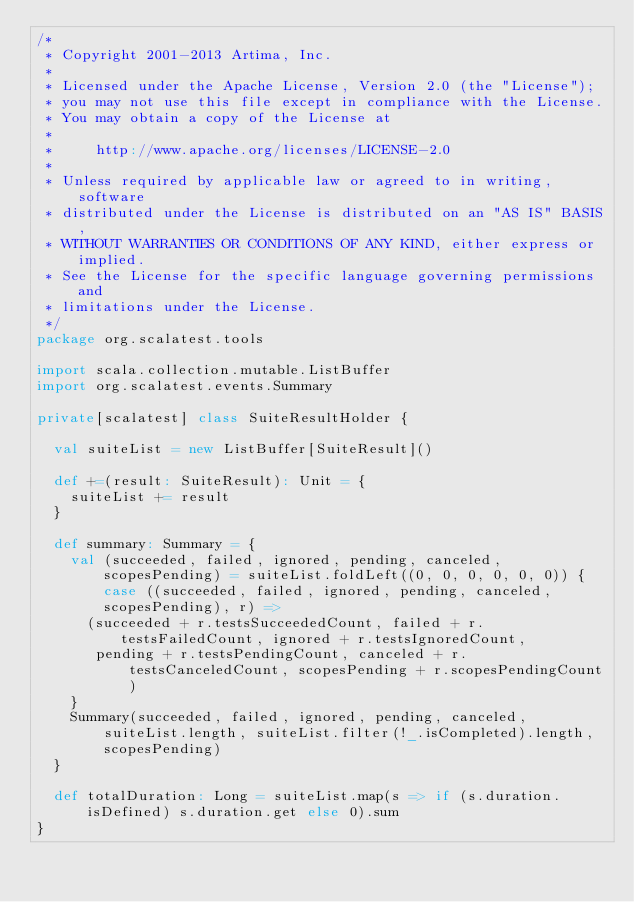Convert code to text. <code><loc_0><loc_0><loc_500><loc_500><_Scala_>/*
 * Copyright 2001-2013 Artima, Inc.
 *
 * Licensed under the Apache License, Version 2.0 (the "License");
 * you may not use this file except in compliance with the License.
 * You may obtain a copy of the License at
 *
 *     http://www.apache.org/licenses/LICENSE-2.0
 *
 * Unless required by applicable law or agreed to in writing, software
 * distributed under the License is distributed on an "AS IS" BASIS,
 * WITHOUT WARRANTIES OR CONDITIONS OF ANY KIND, either express or implied.
 * See the License for the specific language governing permissions and
 * limitations under the License.
 */
package org.scalatest.tools

import scala.collection.mutable.ListBuffer
import org.scalatest.events.Summary

private[scalatest] class SuiteResultHolder {

  val suiteList = new ListBuffer[SuiteResult]()
  
  def +=(result: SuiteResult): Unit = {
    suiteList += result
  }
  
  def summary: Summary = {
    val (succeeded, failed, ignored, pending, canceled, scopesPending) = suiteList.foldLeft((0, 0, 0, 0, 0, 0)) { case ((succeeded, failed, ignored, pending, canceled, scopesPending), r) =>
      (succeeded + r.testsSucceededCount, failed + r.testsFailedCount, ignored + r.testsIgnoredCount, 
       pending + r.testsPendingCount, canceled + r.testsCanceledCount, scopesPending + r.scopesPendingCount)
    }
    Summary(succeeded, failed, ignored, pending, canceled, suiteList.length, suiteList.filter(!_.isCompleted).length, scopesPending)
  }
  
  def totalDuration: Long = suiteList.map(s => if (s.duration.isDefined) s.duration.get else 0).sum
}
</code> 